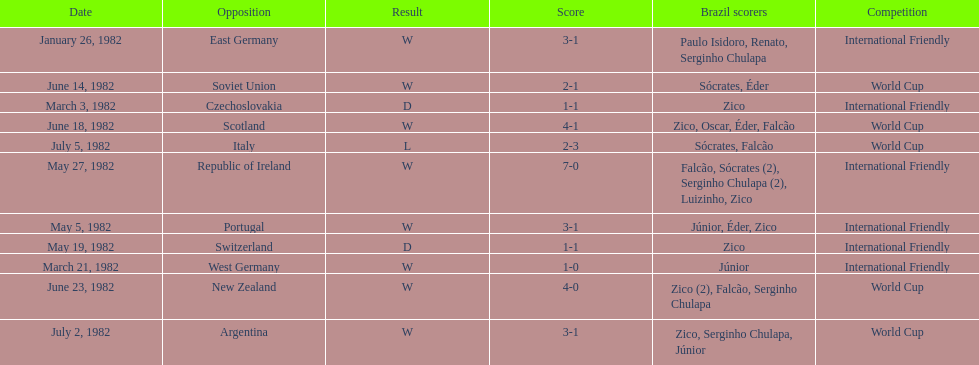What are the dates January 26, 1982, March 3, 1982, March 21, 1982, May 5, 1982, May 19, 1982, May 27, 1982, June 14, 1982, June 18, 1982, June 23, 1982, July 2, 1982, July 5, 1982. Which date is at the top? January 26, 1982. 